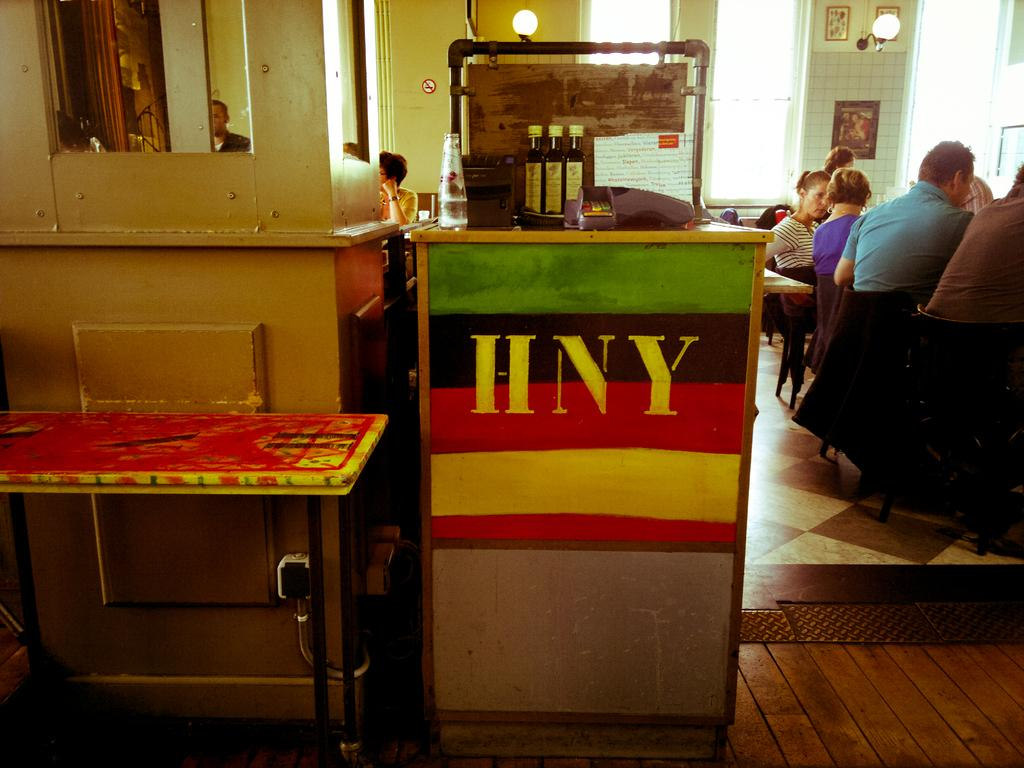What type of table is in the image? There is a wooden table in the image. What can be found on the wooden table? There are objects on the wooden table. Can you describe the people in relation to the wooden table? There are people beside and behind the wooden table. What channel is the wooden table tuned to in the image? The wooden table is not a television or device that can be tuned to a channel; it is a piece of furniture. 